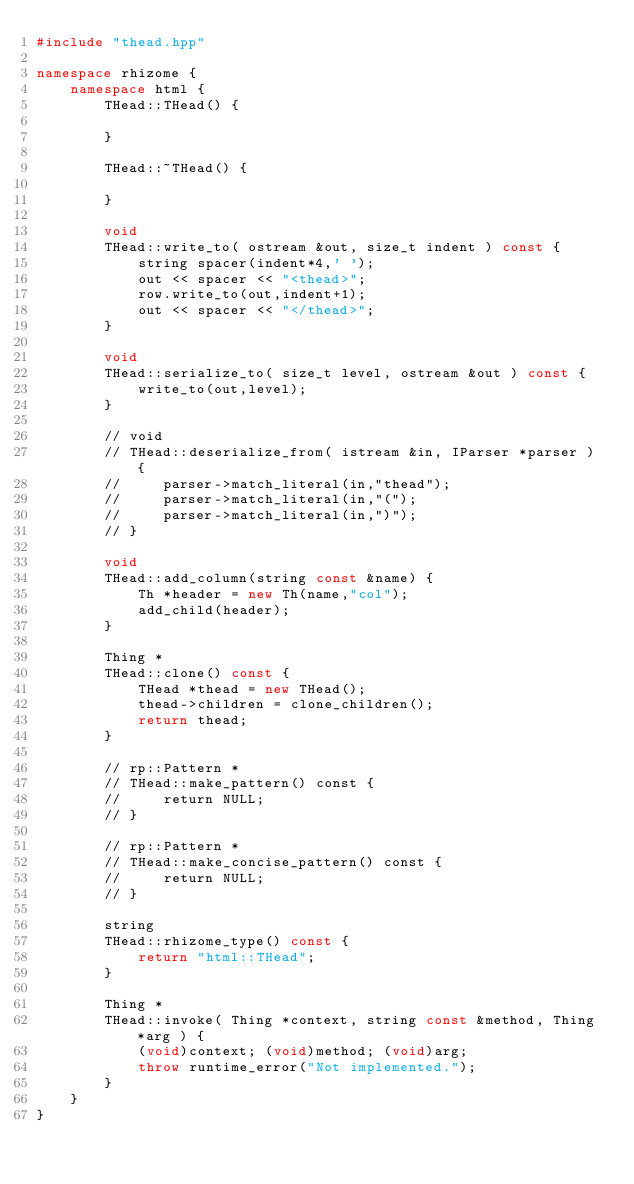Convert code to text. <code><loc_0><loc_0><loc_500><loc_500><_C++_>#include "thead.hpp"

namespace rhizome {
    namespace html {
        THead::THead() {

        }

        THead::~THead() {

        }

        void
        THead::write_to( ostream &out, size_t indent ) const {
            string spacer(indent*4,' ');
            out << spacer << "<thead>";
            row.write_to(out,indent+1);
            out << spacer << "</thead>";
        }

        void
        THead::serialize_to( size_t level, ostream &out ) const {
            write_to(out,level);
        }

        // void
        // THead::deserialize_from( istream &in, IParser *parser ) {
        //     parser->match_literal(in,"thead");
        //     parser->match_literal(in,"(");
        //     parser->match_literal(in,")");
        // }

        void
        THead::add_column(string const &name) {
            Th *header = new Th(name,"col");
            add_child(header);
        }

        Thing * 
        THead::clone() const {
            THead *thead = new THead();
            thead->children = clone_children();
            return thead;
        }

        // rp::Pattern *
        // THead::make_pattern() const {
        //     return NULL;
        // }

        // rp::Pattern *
        // THead::make_concise_pattern() const {
        //     return NULL;
        // }

        string
        THead::rhizome_type() const {
            return "html::THead";
        }

        Thing *
        THead::invoke( Thing *context, string const &method, Thing *arg ) {
            (void)context; (void)method; (void)arg;
            throw runtime_error("Not implemented.");
        }
    }
}</code> 